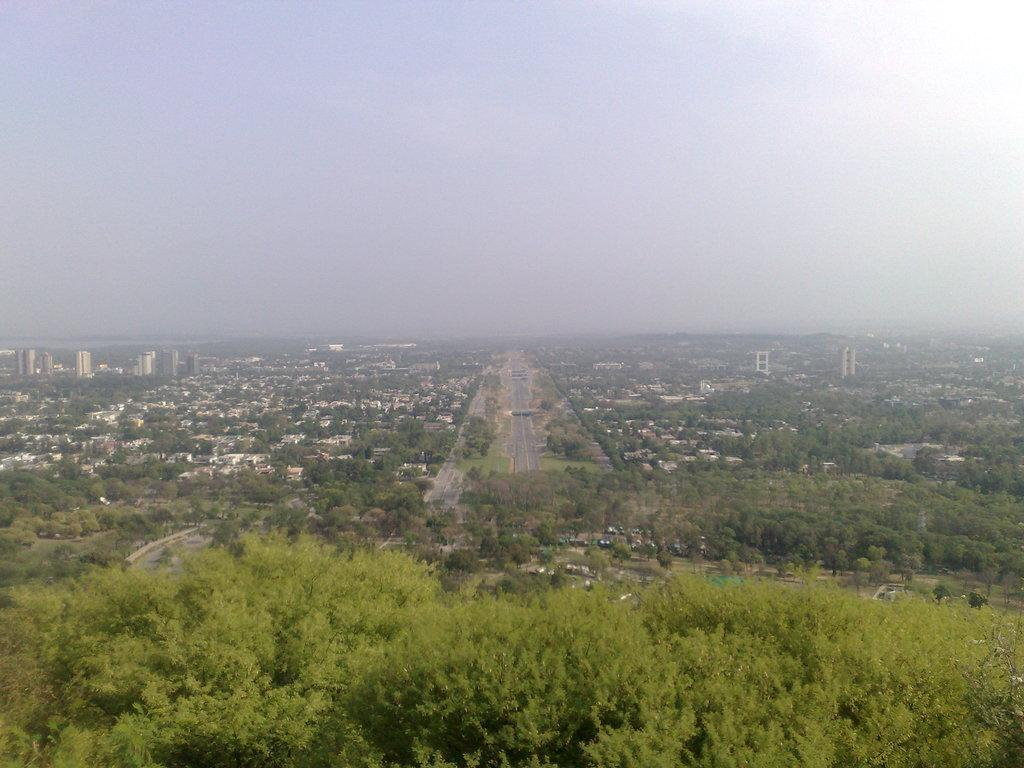What type of natural vegetation is visible in the image? There are trees in the image. What type of man-made structures can be seen in the image? There are buildings in the image. What type of transportation infrastructure is present in the image? There are roads in the image. What is visible in the background of the image? The sky is visible in the background of the image. Can you tell me how many eggs are visible in the image? There are no eggs present in the image. What type of sea creature can be seen swimming in the image? There is no sea or any sea creatures present in the image. 